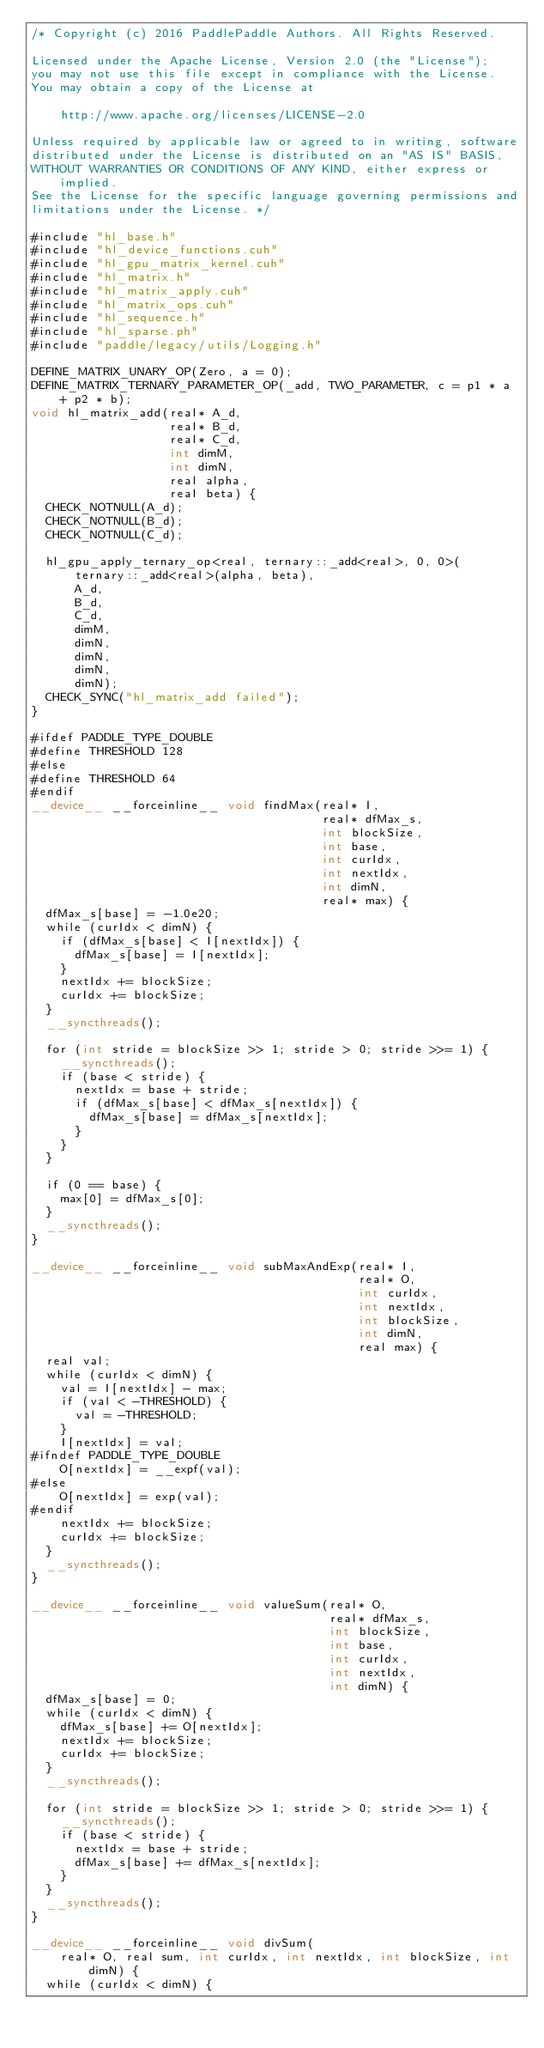<code> <loc_0><loc_0><loc_500><loc_500><_Cuda_>/* Copyright (c) 2016 PaddlePaddle Authors. All Rights Reserved.

Licensed under the Apache License, Version 2.0 (the "License");
you may not use this file except in compliance with the License.
You may obtain a copy of the License at

    http://www.apache.org/licenses/LICENSE-2.0

Unless required by applicable law or agreed to in writing, software
distributed under the License is distributed on an "AS IS" BASIS,
WITHOUT WARRANTIES OR CONDITIONS OF ANY KIND, either express or implied.
See the License for the specific language governing permissions and
limitations under the License. */

#include "hl_base.h"
#include "hl_device_functions.cuh"
#include "hl_gpu_matrix_kernel.cuh"
#include "hl_matrix.h"
#include "hl_matrix_apply.cuh"
#include "hl_matrix_ops.cuh"
#include "hl_sequence.h"
#include "hl_sparse.ph"
#include "paddle/legacy/utils/Logging.h"

DEFINE_MATRIX_UNARY_OP(Zero, a = 0);
DEFINE_MATRIX_TERNARY_PARAMETER_OP(_add, TWO_PARAMETER, c = p1 * a + p2 * b);
void hl_matrix_add(real* A_d,
                   real* B_d,
                   real* C_d,
                   int dimM,
                   int dimN,
                   real alpha,
                   real beta) {
  CHECK_NOTNULL(A_d);
  CHECK_NOTNULL(B_d);
  CHECK_NOTNULL(C_d);

  hl_gpu_apply_ternary_op<real, ternary::_add<real>, 0, 0>(
      ternary::_add<real>(alpha, beta),
      A_d,
      B_d,
      C_d,
      dimM,
      dimN,
      dimN,
      dimN,
      dimN);
  CHECK_SYNC("hl_matrix_add failed");
}

#ifdef PADDLE_TYPE_DOUBLE
#define THRESHOLD 128
#else
#define THRESHOLD 64
#endif
__device__ __forceinline__ void findMax(real* I,
                                        real* dfMax_s,
                                        int blockSize,
                                        int base,
                                        int curIdx,
                                        int nextIdx,
                                        int dimN,
                                        real* max) {
  dfMax_s[base] = -1.0e20;
  while (curIdx < dimN) {
    if (dfMax_s[base] < I[nextIdx]) {
      dfMax_s[base] = I[nextIdx];
    }
    nextIdx += blockSize;
    curIdx += blockSize;
  }
  __syncthreads();

  for (int stride = blockSize >> 1; stride > 0; stride >>= 1) {
    __syncthreads();
    if (base < stride) {
      nextIdx = base + stride;
      if (dfMax_s[base] < dfMax_s[nextIdx]) {
        dfMax_s[base] = dfMax_s[nextIdx];
      }
    }
  }

  if (0 == base) {
    max[0] = dfMax_s[0];
  }
  __syncthreads();
}

__device__ __forceinline__ void subMaxAndExp(real* I,
                                             real* O,
                                             int curIdx,
                                             int nextIdx,
                                             int blockSize,
                                             int dimN,
                                             real max) {
  real val;
  while (curIdx < dimN) {
    val = I[nextIdx] - max;
    if (val < -THRESHOLD) {
      val = -THRESHOLD;
    }
    I[nextIdx] = val;
#ifndef PADDLE_TYPE_DOUBLE
    O[nextIdx] = __expf(val);
#else
    O[nextIdx] = exp(val);
#endif
    nextIdx += blockSize;
    curIdx += blockSize;
  }
  __syncthreads();
}

__device__ __forceinline__ void valueSum(real* O,
                                         real* dfMax_s,
                                         int blockSize,
                                         int base,
                                         int curIdx,
                                         int nextIdx,
                                         int dimN) {
  dfMax_s[base] = 0;
  while (curIdx < dimN) {
    dfMax_s[base] += O[nextIdx];
    nextIdx += blockSize;
    curIdx += blockSize;
  }
  __syncthreads();

  for (int stride = blockSize >> 1; stride > 0; stride >>= 1) {
    __syncthreads();
    if (base < stride) {
      nextIdx = base + stride;
      dfMax_s[base] += dfMax_s[nextIdx];
    }
  }
  __syncthreads();
}

__device__ __forceinline__ void divSum(
    real* O, real sum, int curIdx, int nextIdx, int blockSize, int dimN) {
  while (curIdx < dimN) {</code> 